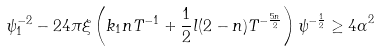Convert formula to latex. <formula><loc_0><loc_0><loc_500><loc_500>\psi _ { 1 } ^ { - 2 } - 2 4 \pi \xi \left ( k _ { 1 } n T ^ { - 1 } + \frac { 1 } { 2 } l ( 2 - n ) T ^ { - \frac { 5 n } { 2 } } \right ) \psi ^ { - \frac { 1 } { 2 } } \geq { 4 \alpha } ^ { 2 }</formula> 